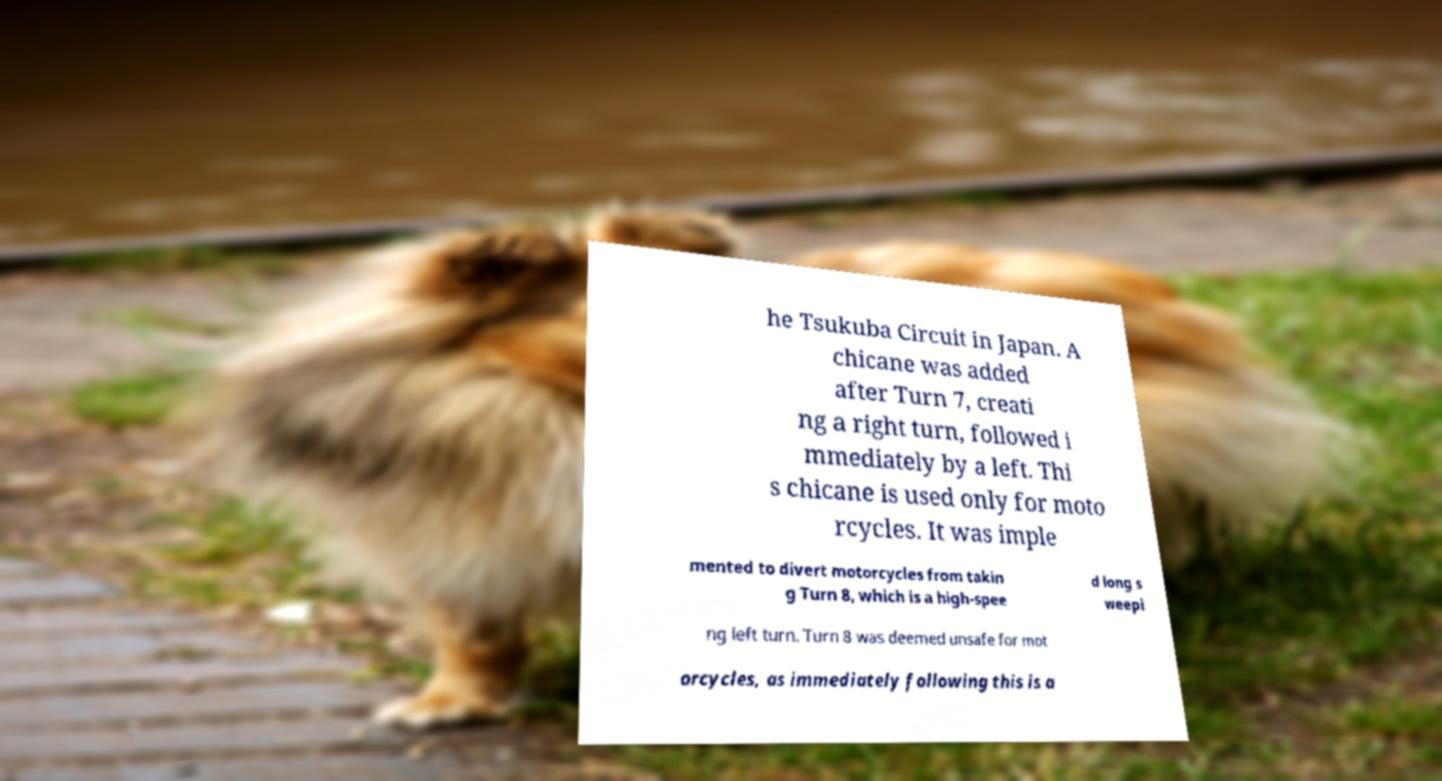Could you assist in decoding the text presented in this image and type it out clearly? he Tsukuba Circuit in Japan. A chicane was added after Turn 7, creati ng a right turn, followed i mmediately by a left. Thi s chicane is used only for moto rcycles. It was imple mented to divert motorcycles from takin g Turn 8, which is a high-spee d long s weepi ng left turn. Turn 8 was deemed unsafe for mot orcycles, as immediately following this is a 